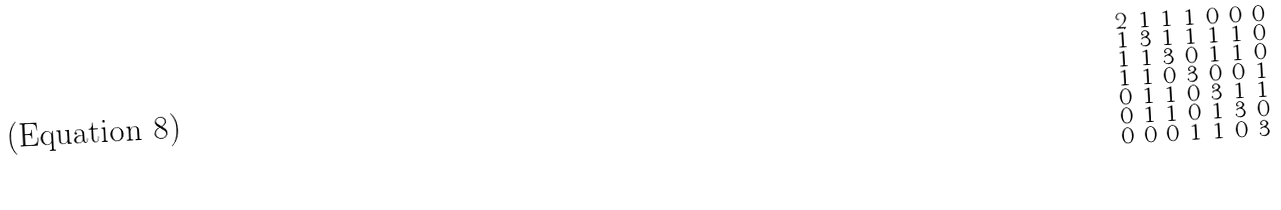Convert formula to latex. <formula><loc_0><loc_0><loc_500><loc_500>\begin{smallmatrix} 2 & 1 & 1 & 1 & 0 & 0 & 0 \\ 1 & 3 & 1 & 1 & 1 & 1 & 0 \\ 1 & 1 & 3 & 0 & 1 & 1 & 0 \\ 1 & 1 & 0 & 3 & 0 & 0 & 1 \\ 0 & 1 & 1 & 0 & 3 & 1 & 1 \\ 0 & 1 & 1 & 0 & 1 & 3 & 0 \\ 0 & 0 & 0 & 1 & 1 & 0 & 3 \end{smallmatrix}</formula> 